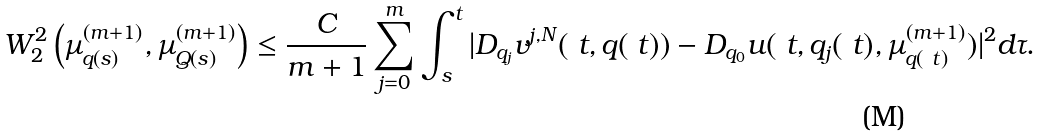<formula> <loc_0><loc_0><loc_500><loc_500>W _ { 2 } ^ { 2 } \left ( \mu ^ { ( m + 1 ) } _ { q ( s ) } , \mu ^ { ( m + 1 ) } _ { Q ( s ) } \right ) & \leq \frac { C } { m + 1 } \sum _ { j = 0 } ^ { m } \int _ { s } ^ { t } | D _ { q _ { j } } v ^ { j , N } ( \ t , q ( \ t ) ) - D _ { q _ { 0 } } u ( \ t , q _ { j } ( \ t ) , \mu ^ { ( m + 1 ) } _ { q ( \ t ) } ) | ^ { 2 } d \tau .</formula> 